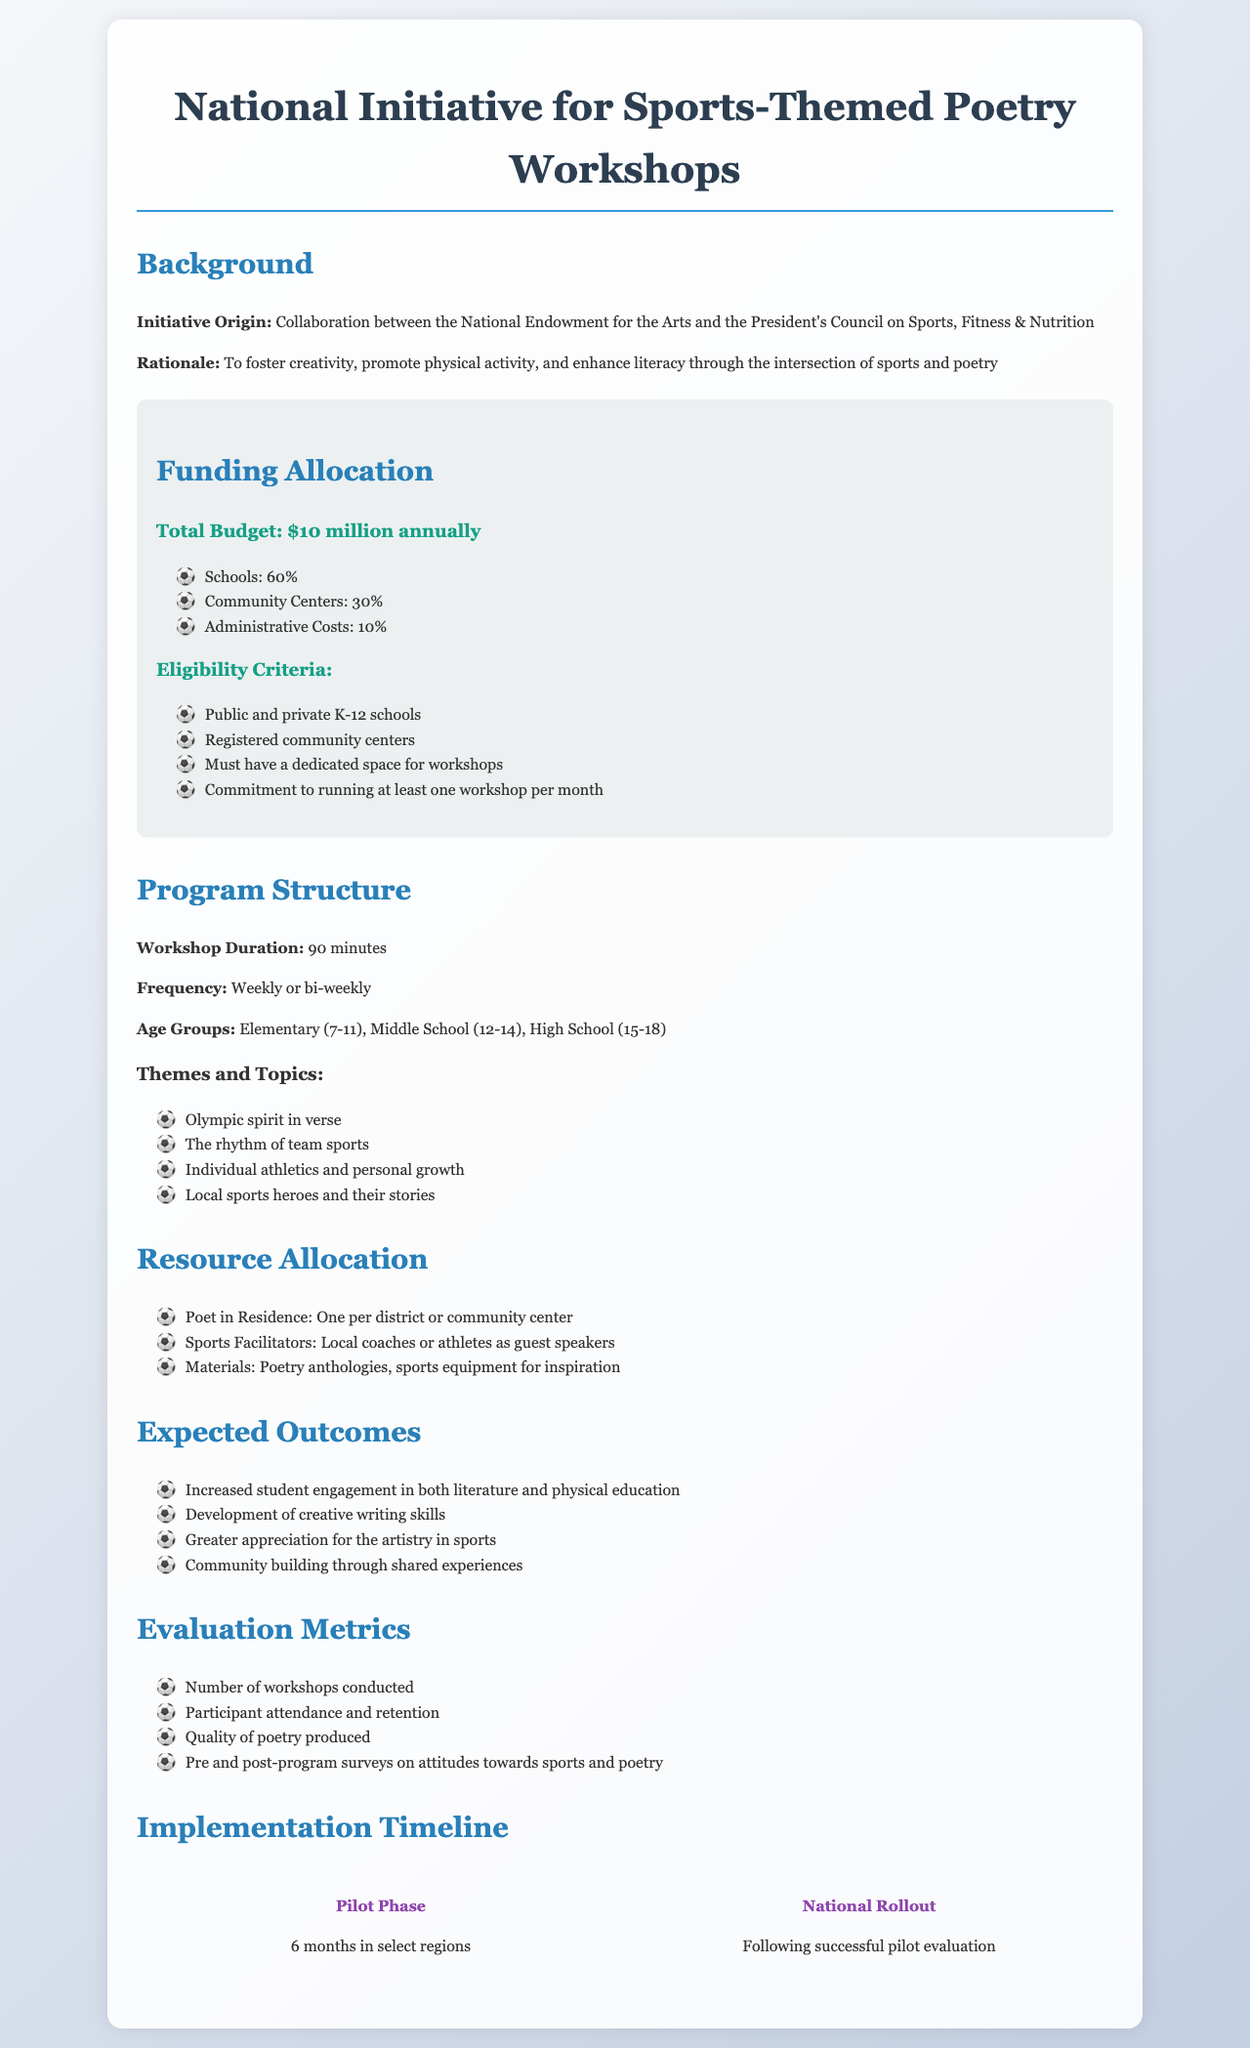What is the total budget for the initiative? The total budget is specified in the funding allocation section of the document.
Answer: $10 million annually What percentage of funding is allocated to community centers? The percentage allocations are detailed in the funding box within the document.
Answer: 30% What is the minimum frequency of workshops required? This information is found in the eligibility criteria of the funding allocation section.
Answer: At least one workshop per month Who collaborates in the initiative's origin? The document mentions the organizations involved in the initiative's origin.
Answer: National Endowment for the Arts and the President's Council on Sports, Fitness & Nutrition What is one expected outcome of the program? The expected outcomes are listed in the outcomes section of the document.
Answer: Increased student engagement in both literature and physical education How long is each workshop planned to last? The duration of each workshop is specified in the program structure section.
Answer: 90 minutes What are the age groups targeted by the workshops? The targeted age groups are outlined in the program structure section.
Answer: Elementary (7-11), Middle School (12-14), High School (15-18) What kind of resource is provided in each district or community center? Resources allocated are defined in the resource allocation section of the document.
Answer: Poet in Residence 